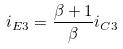Convert formula to latex. <formula><loc_0><loc_0><loc_500><loc_500>i _ { E 3 } = \frac { \beta + 1 } { \beta } i _ { C 3 }</formula> 